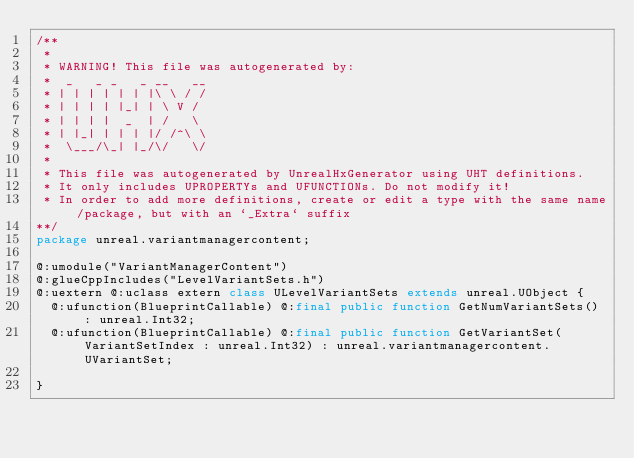Convert code to text. <code><loc_0><loc_0><loc_500><loc_500><_Haxe_>/**
 * 
 * WARNING! This file was autogenerated by: 
 *  _   _ _   _ __   __ 
 * | | | | | | |\ \ / / 
 * | | | | |_| | \ V /  
 * | | | |  _  | /   \  
 * | |_| | | | |/ /^\ \ 
 *  \___/\_| |_/\/   \/ 
 * 
 * This file was autogenerated by UnrealHxGenerator using UHT definitions.
 * It only includes UPROPERTYs and UFUNCTIONs. Do not modify it!
 * In order to add more definitions, create or edit a type with the same name/package, but with an `_Extra` suffix
**/
package unreal.variantmanagercontent;

@:umodule("VariantManagerContent")
@:glueCppIncludes("LevelVariantSets.h")
@:uextern @:uclass extern class ULevelVariantSets extends unreal.UObject {
  @:ufunction(BlueprintCallable) @:final public function GetNumVariantSets() : unreal.Int32;
  @:ufunction(BlueprintCallable) @:final public function GetVariantSet(VariantSetIndex : unreal.Int32) : unreal.variantmanagercontent.UVariantSet;
  
}
</code> 